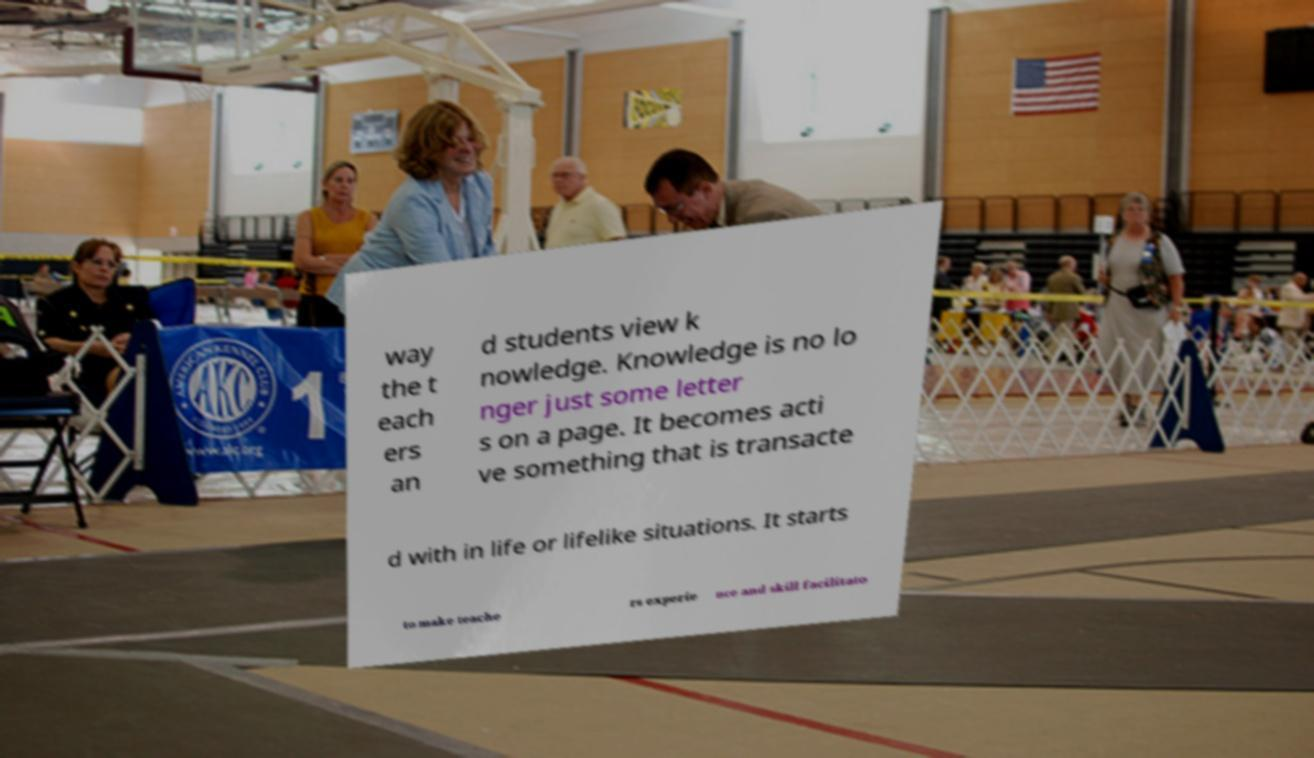Can you read and provide the text displayed in the image?This photo seems to have some interesting text. Can you extract and type it out for me? way the t each ers an d students view k nowledge. Knowledge is no lo nger just some letter s on a page. It becomes acti ve something that is transacte d with in life or lifelike situations. It starts to make teache rs experie nce and skill facilitato 